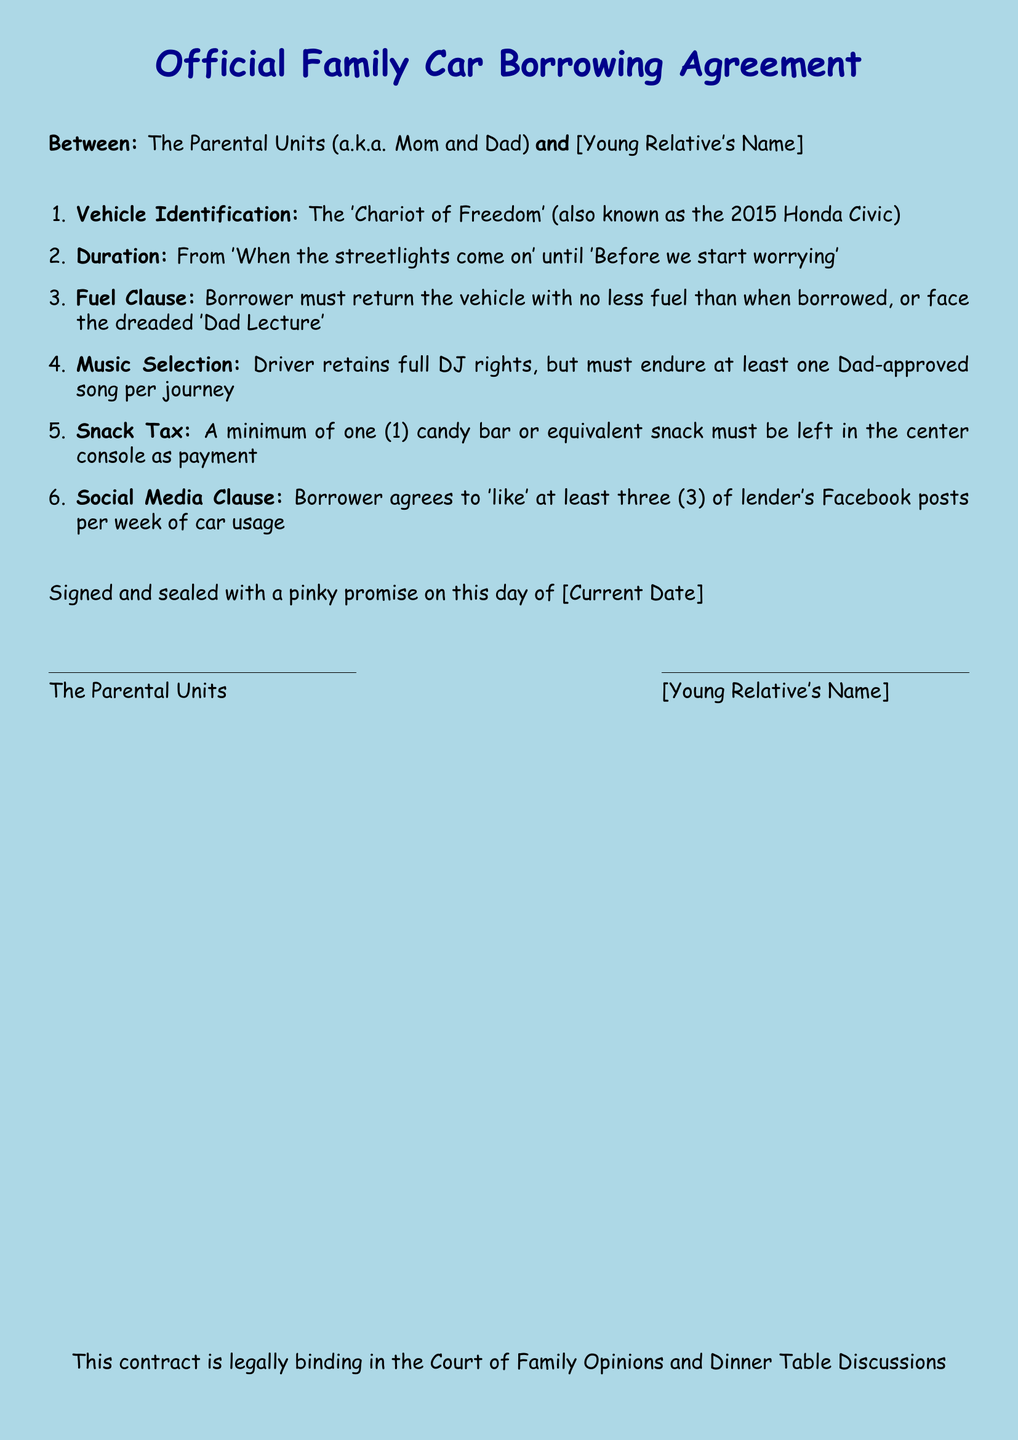What is the vehicle's name? The vehicle is referred to as 'Chariot of Freedom' in the document.
Answer: 'Chariot of Freedom' What is the duration of the car borrowing? The duration is defined as 'When the streetlights come on' until 'Before we start worrying'.
Answer: 'When the streetlights come on' until 'Before we start worrying' What must be left in the center console? The document states that a minimum of one candy bar or equivalent snack must be left.
Answer: one candy bar How many Facebook posts must be liked per week? The borrower agrees to 'like' at least three Facebook posts per week of car usage.
Answer: three What is the title of the document? The official title displayed at the top of the document is 'Official Family Car Borrowing Agreement'.
Answer: Official Family Car Borrowing Agreement What clause involves music? The document mentions a 'Music Selection' clause regarding the driver's DJ rights.
Answer: Music Selection Who are the parties involved in the agreement? The agreement is between the Parental Units (Mom and Dad) and the young relative.
Answer: The Parental Units (a.k.a. Mom and Dad) and [Young Relative's Name] What is the consequence of not returning the vehicle with enough fuel? The consequence is facing the dreaded 'Dad Lecture' according to the Fuel Clause.
Answer: 'Dad Lecture' On which date is the contract signed? The document states it is signed on the day of [Current Date].
Answer: [Current Date] 